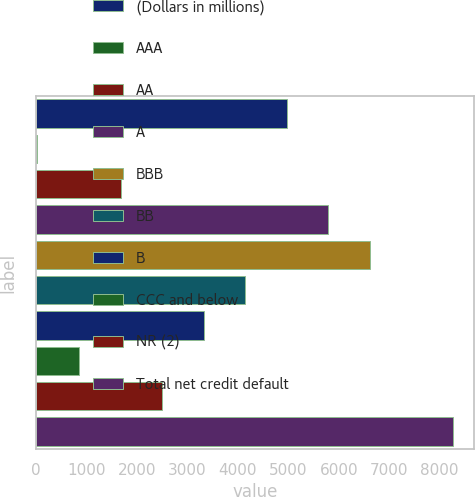Convert chart to OTSL. <chart><loc_0><loc_0><loc_500><loc_500><bar_chart><fcel>(Dollars in millions)<fcel>AAA<fcel>AA<fcel>A<fcel>BBB<fcel>BB<fcel>B<fcel>CCC and below<fcel>NR (2)<fcel>Total net credit default<nl><fcel>4965.2<fcel>23<fcel>1670.4<fcel>5788.9<fcel>6612.6<fcel>4141.5<fcel>3317.8<fcel>846.7<fcel>2494.1<fcel>8260<nl></chart> 